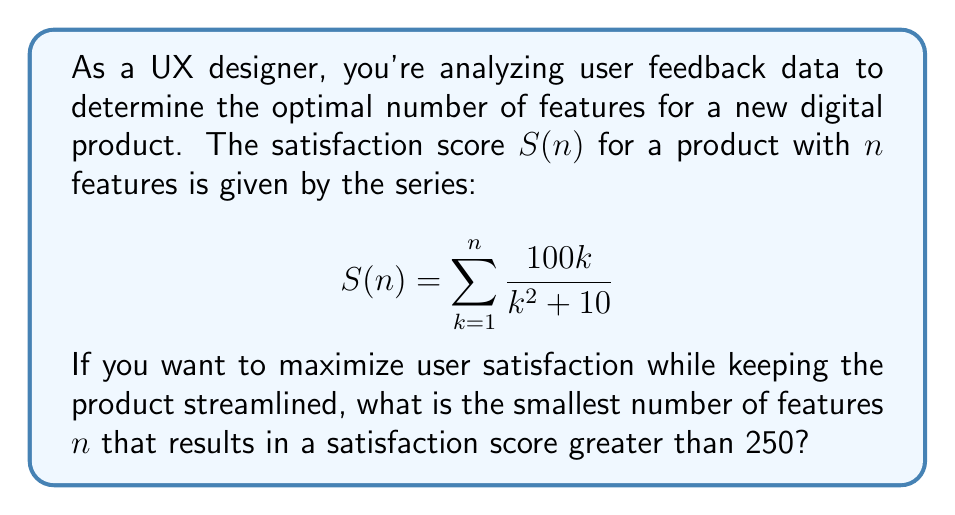Can you answer this question? To solve this problem, we need to evaluate the series for increasing values of $n$ until we find the first one that exceeds 250. Let's break it down step-by-step:

1) First, let's calculate the series for the first few values of $n$:

   For $n = 1$: $S(1) = \frac{100(1)}{1^2 + 10} = \frac{100}{11} \approx 9.09$

   For $n = 2$: $S(2) = \frac{100(1)}{1^2 + 10} + \frac{100(2)}{2^2 + 10} = \frac{100}{11} + \frac{200}{14} \approx 23.38$

2) We can see that we need to continue this process for larger $n$. Let's use a cumulative sum approach:

   For $n = 3$: $S(3) \approx 23.38 + \frac{100(3)}{3^2 + 10} \approx 44.38$
   
   For $n = 4$: $S(4) \approx 44.38 + \frac{100(4)}{4^2 + 10} \approx 70.38$

3) Continuing this process:

   $S(5) \approx 100.38$
   $S(6) \approx 133.05$
   $S(7) \approx 167.05$
   $S(8) \approx 201.05$
   $S(9) \approx 234.05$
   $S(10) \approx 265.34$

4) We can see that $S(10)$ is the first value to exceed 250.

Therefore, the smallest number of features that results in a satisfaction score greater than 250 is 10.
Answer: 10 features 